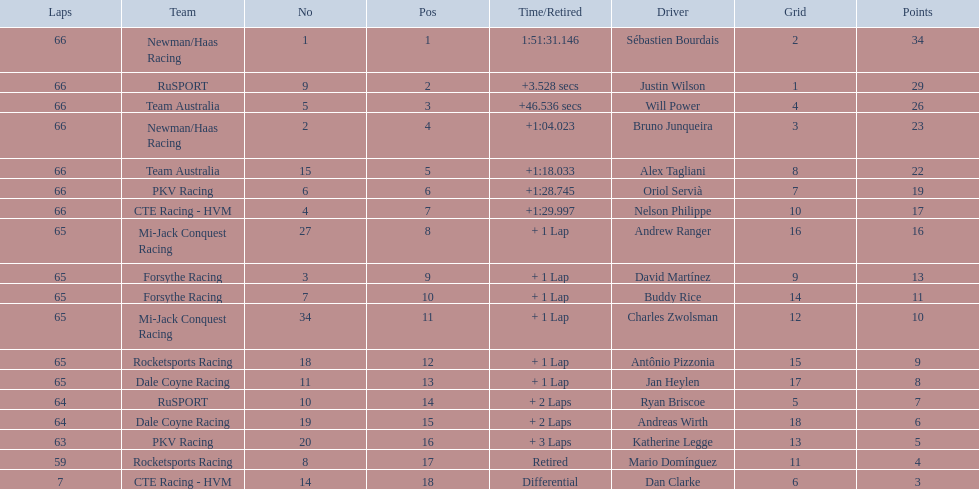Who are the drivers? Sébastien Bourdais, Justin Wilson, Will Power, Bruno Junqueira, Alex Tagliani, Oriol Servià, Nelson Philippe, Andrew Ranger, David Martínez, Buddy Rice, Charles Zwolsman, Antônio Pizzonia, Jan Heylen, Ryan Briscoe, Andreas Wirth, Katherine Legge, Mario Domínguez, Dan Clarke. What are their numbers? 1, 9, 5, 2, 15, 6, 4, 27, 3, 7, 34, 18, 11, 10, 19, 20, 8, 14. What are their positions? 1, 2, 3, 4, 5, 6, 7, 8, 9, 10, 11, 12, 13, 14, 15, 16, 17, 18. Which driver has the same number and position? Sébastien Bourdais. 